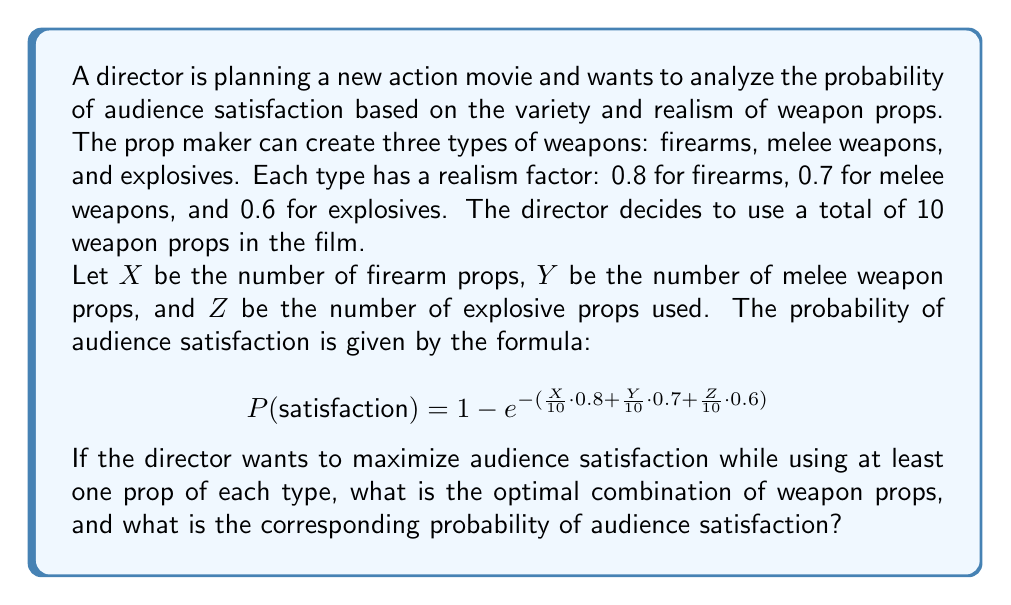Teach me how to tackle this problem. To solve this problem, we need to find the optimal combination of $X$, $Y$, and $Z$ that maximizes the probability of audience satisfaction, given the constraints:

1. $X + Y + Z = 10$ (total number of props)
2. $X \geq 1$, $Y \geq 1$, $Z \geq 1$ (at least one prop of each type)

Let's approach this step-by-step:

1) First, we can see that firearms have the highest realism factor (0.8), followed by melee weapons (0.7), and then explosives (0.6). This suggests that we should prioritize firearms, then melee weapons, and finally explosives.

2) Given the constraints, the minimum number of props for each type is 1. So, we start with $X = 1$, $Y = 1$, $Z = 1$.

3) We have 7 props left to distribute. Since firearms have the highest realism factor, we should allocate as many as possible to firearms. This gives us:

   $X = 8$, $Y = 1$, $Z = 1$

4) Now, let's calculate the probability of satisfaction for this combination:

   $$P(\text{satisfaction}) = 1 - e^{-(\frac{8}{10} \cdot 0.8 + \frac{1}{10} \cdot 0.7 + \frac{1}{10} \cdot 0.6)}$$
   $$= 1 - e^{-(0.64 + 0.07 + 0.06)}$$
   $$= 1 - e^{-0.77}$$
   $$\approx 0.5369$$

5) To verify this is indeed the optimal combination, we can check the next best alternative: $X = 7$, $Y = 2$, $Z = 1$

   $$P(\text{satisfaction}) = 1 - e^{-(\frac{7}{10} \cdot 0.8 + \frac{2}{10} \cdot 0.7 + \frac{1}{10} \cdot 0.6)}$$
   $$= 1 - e^{-(0.56 + 0.14 + 0.06)}$$
   $$= 1 - e^{-0.76}$$
   $$\approx 0.5323$$

This confirms that $X = 8$, $Y = 1$, $Z = 1$ is indeed the optimal combination.
Answer: 8 firearms, 1 melee weapon, 1 explosive; $P(\text{satisfaction}) \approx 0.5369$ 